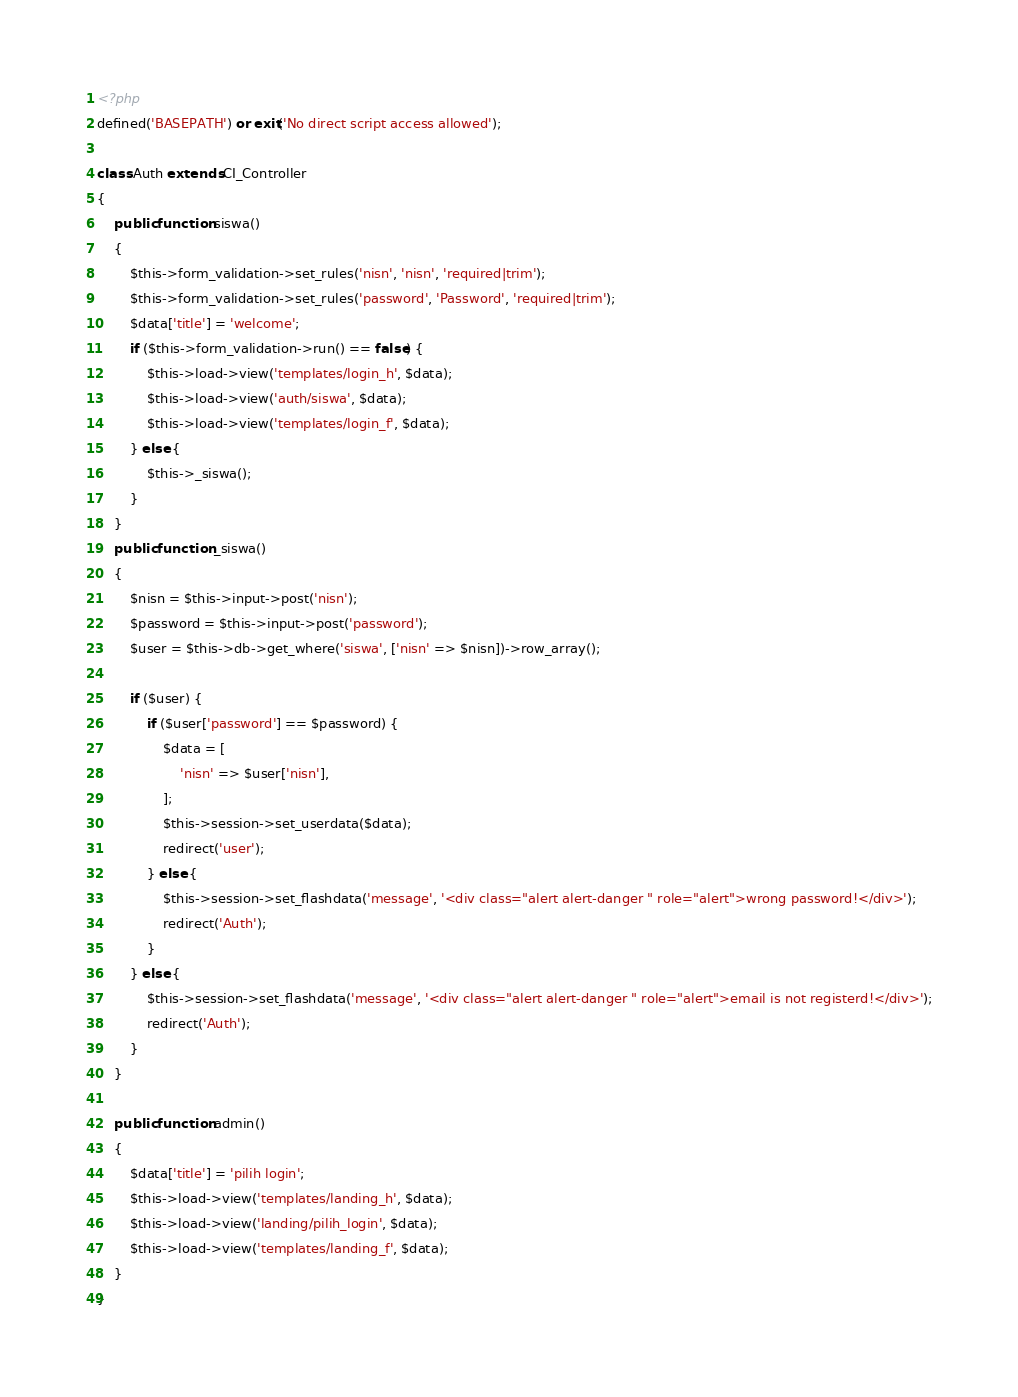Convert code to text. <code><loc_0><loc_0><loc_500><loc_500><_PHP_><?php
defined('BASEPATH') or exit('No direct script access allowed');

class Auth extends CI_Controller
{
    public function siswa()
    {
        $this->form_validation->set_rules('nisn', 'nisn', 'required|trim');
        $this->form_validation->set_rules('password', 'Password', 'required|trim');
        $data['title'] = 'welcome';
        if ($this->form_validation->run() == false) {
            $this->load->view('templates/login_h', $data);
            $this->load->view('auth/siswa', $data);
            $this->load->view('templates/login_f', $data);
        } else {
            $this->_siswa();
        }
    }
    public function _siswa()
    {
        $nisn = $this->input->post('nisn');
        $password = $this->input->post('password');
        $user = $this->db->get_where('siswa', ['nisn' => $nisn])->row_array();

        if ($user) {
            if ($user['password'] == $password) {
                $data = [
                    'nisn' => $user['nisn'],
                ];
                $this->session->set_userdata($data);
                redirect('user');
            } else {
                $this->session->set_flashdata('message', '<div class="alert alert-danger " role="alert">wrong password!</div>');
                redirect('Auth');
            }
        } else {
            $this->session->set_flashdata('message', '<div class="alert alert-danger " role="alert">email is not registerd!</div>');
            redirect('Auth');
        }
    }

    public function admin()
    {
        $data['title'] = 'pilih login';
        $this->load->view('templates/landing_h', $data);
        $this->load->view('landing/pilih_login', $data);
        $this->load->view('templates/landing_f', $data);
    }
}
</code> 